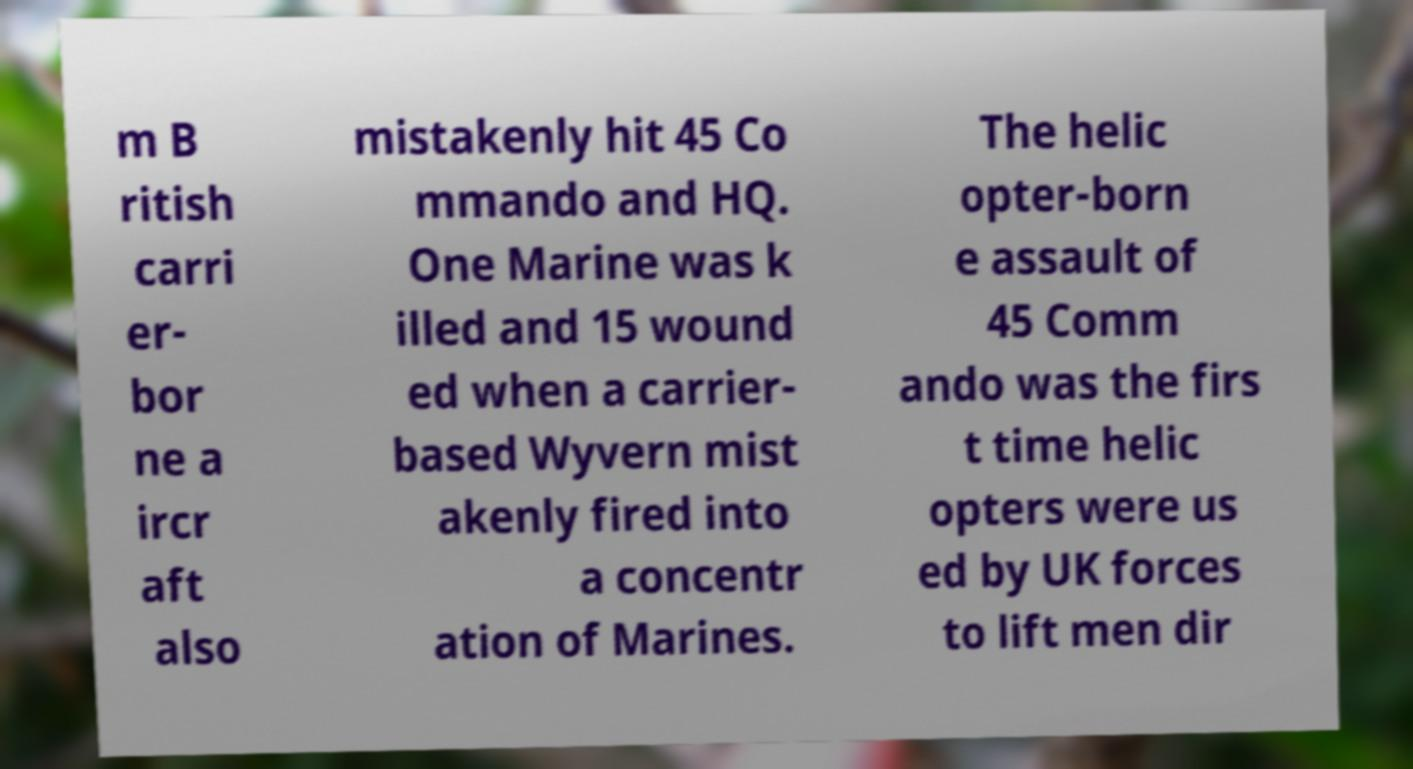Can you read and provide the text displayed in the image?This photo seems to have some interesting text. Can you extract and type it out for me? m B ritish carri er- bor ne a ircr aft also mistakenly hit 45 Co mmando and HQ. One Marine was k illed and 15 wound ed when a carrier- based Wyvern mist akenly fired into a concentr ation of Marines. The helic opter-born e assault of 45 Comm ando was the firs t time helic opters were us ed by UK forces to lift men dir 